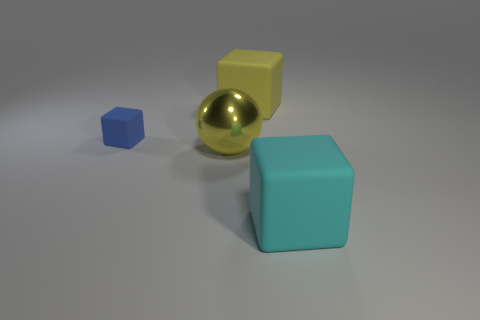What could these objects symbolize if we think of them abstractly? Abstractly, the objects could symbolize various concepts. The blue cube might represent stability or trust, the golden sphere could stand for completeness and value, the yellow cube might symbolize energy and optimism, and the large teal cube could represent calmness or growth. Together, they might represent the unity of different elements or the building blocks of a structure or idea. 